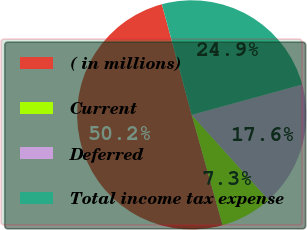Convert chart. <chart><loc_0><loc_0><loc_500><loc_500><pie_chart><fcel>( in millions)<fcel>Current<fcel>Deferred<fcel>Total income tax expense<nl><fcel>50.15%<fcel>7.35%<fcel>17.57%<fcel>24.93%<nl></chart> 